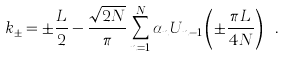<formula> <loc_0><loc_0><loc_500><loc_500>k _ { \pm } = \pm \frac { L } { 2 } - \frac { \sqrt { 2 N } } { \pi } \sum _ { n = 1 } ^ { N } \alpha _ { n } U _ { n - 1 } \left ( \pm \frac { \pi L } { 4 N } \right ) \ .</formula> 